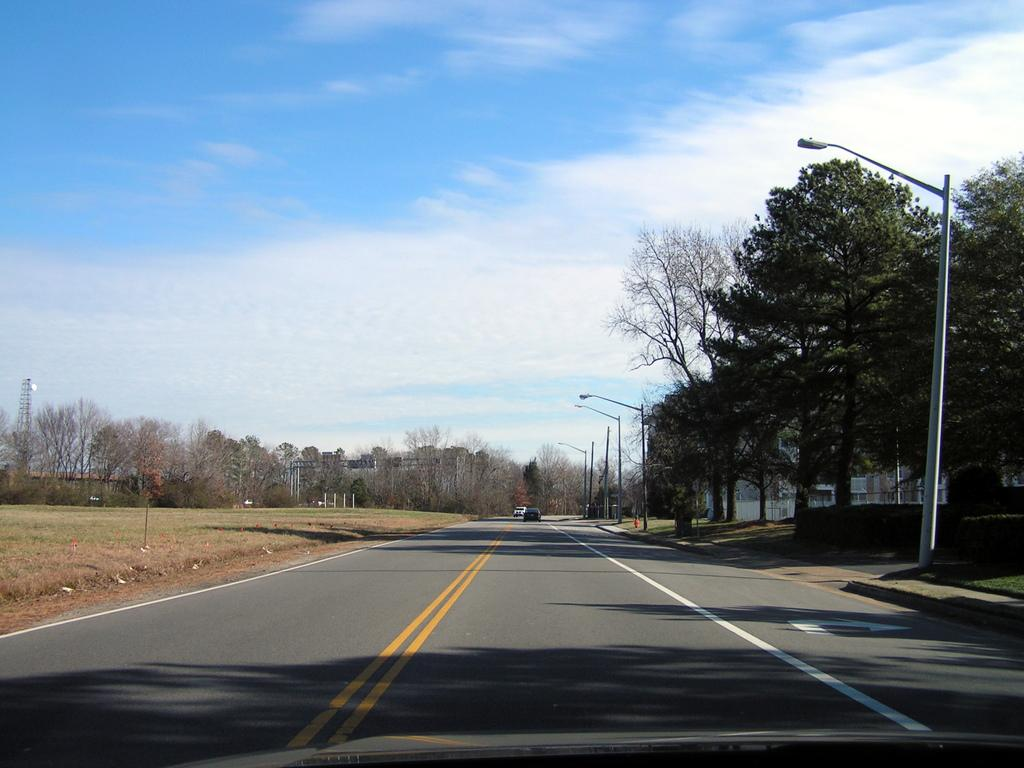What can be seen on the road in the image? There are vehicles on the road in the image. What is located on the right side of the image? There are light poles and trees on the right side of the image. What is visible in the background of the image? There are trees and buildings in the background of the image. What is visible at the top of the image? The sky is visible in the image, and clouds are present in the sky. Can you tell me how many ducks are attempting to cross the road in the image? There are no ducks present in the image, and therefore no such attempt can be observed. What is located in the middle of the image? The image does not have a specific "middle" location, as it is a photograph of a scene with various elements. 